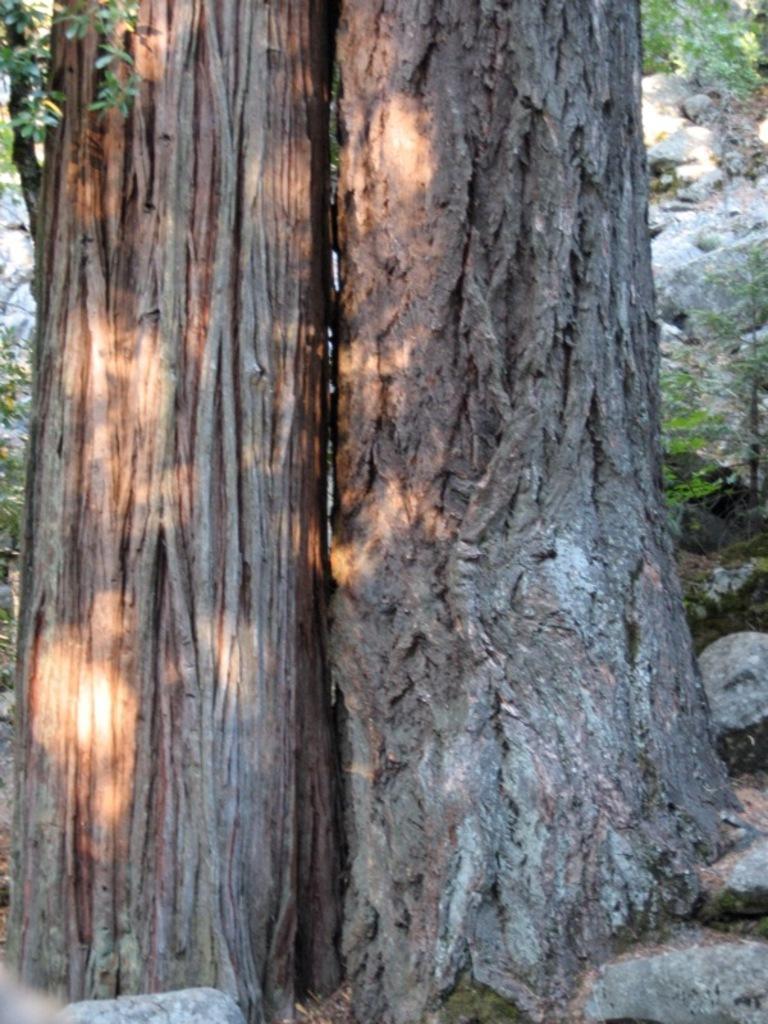How would you summarize this image in a sentence or two? In this image we can see the bark of the trees. We can also see some stones and the leaves. 